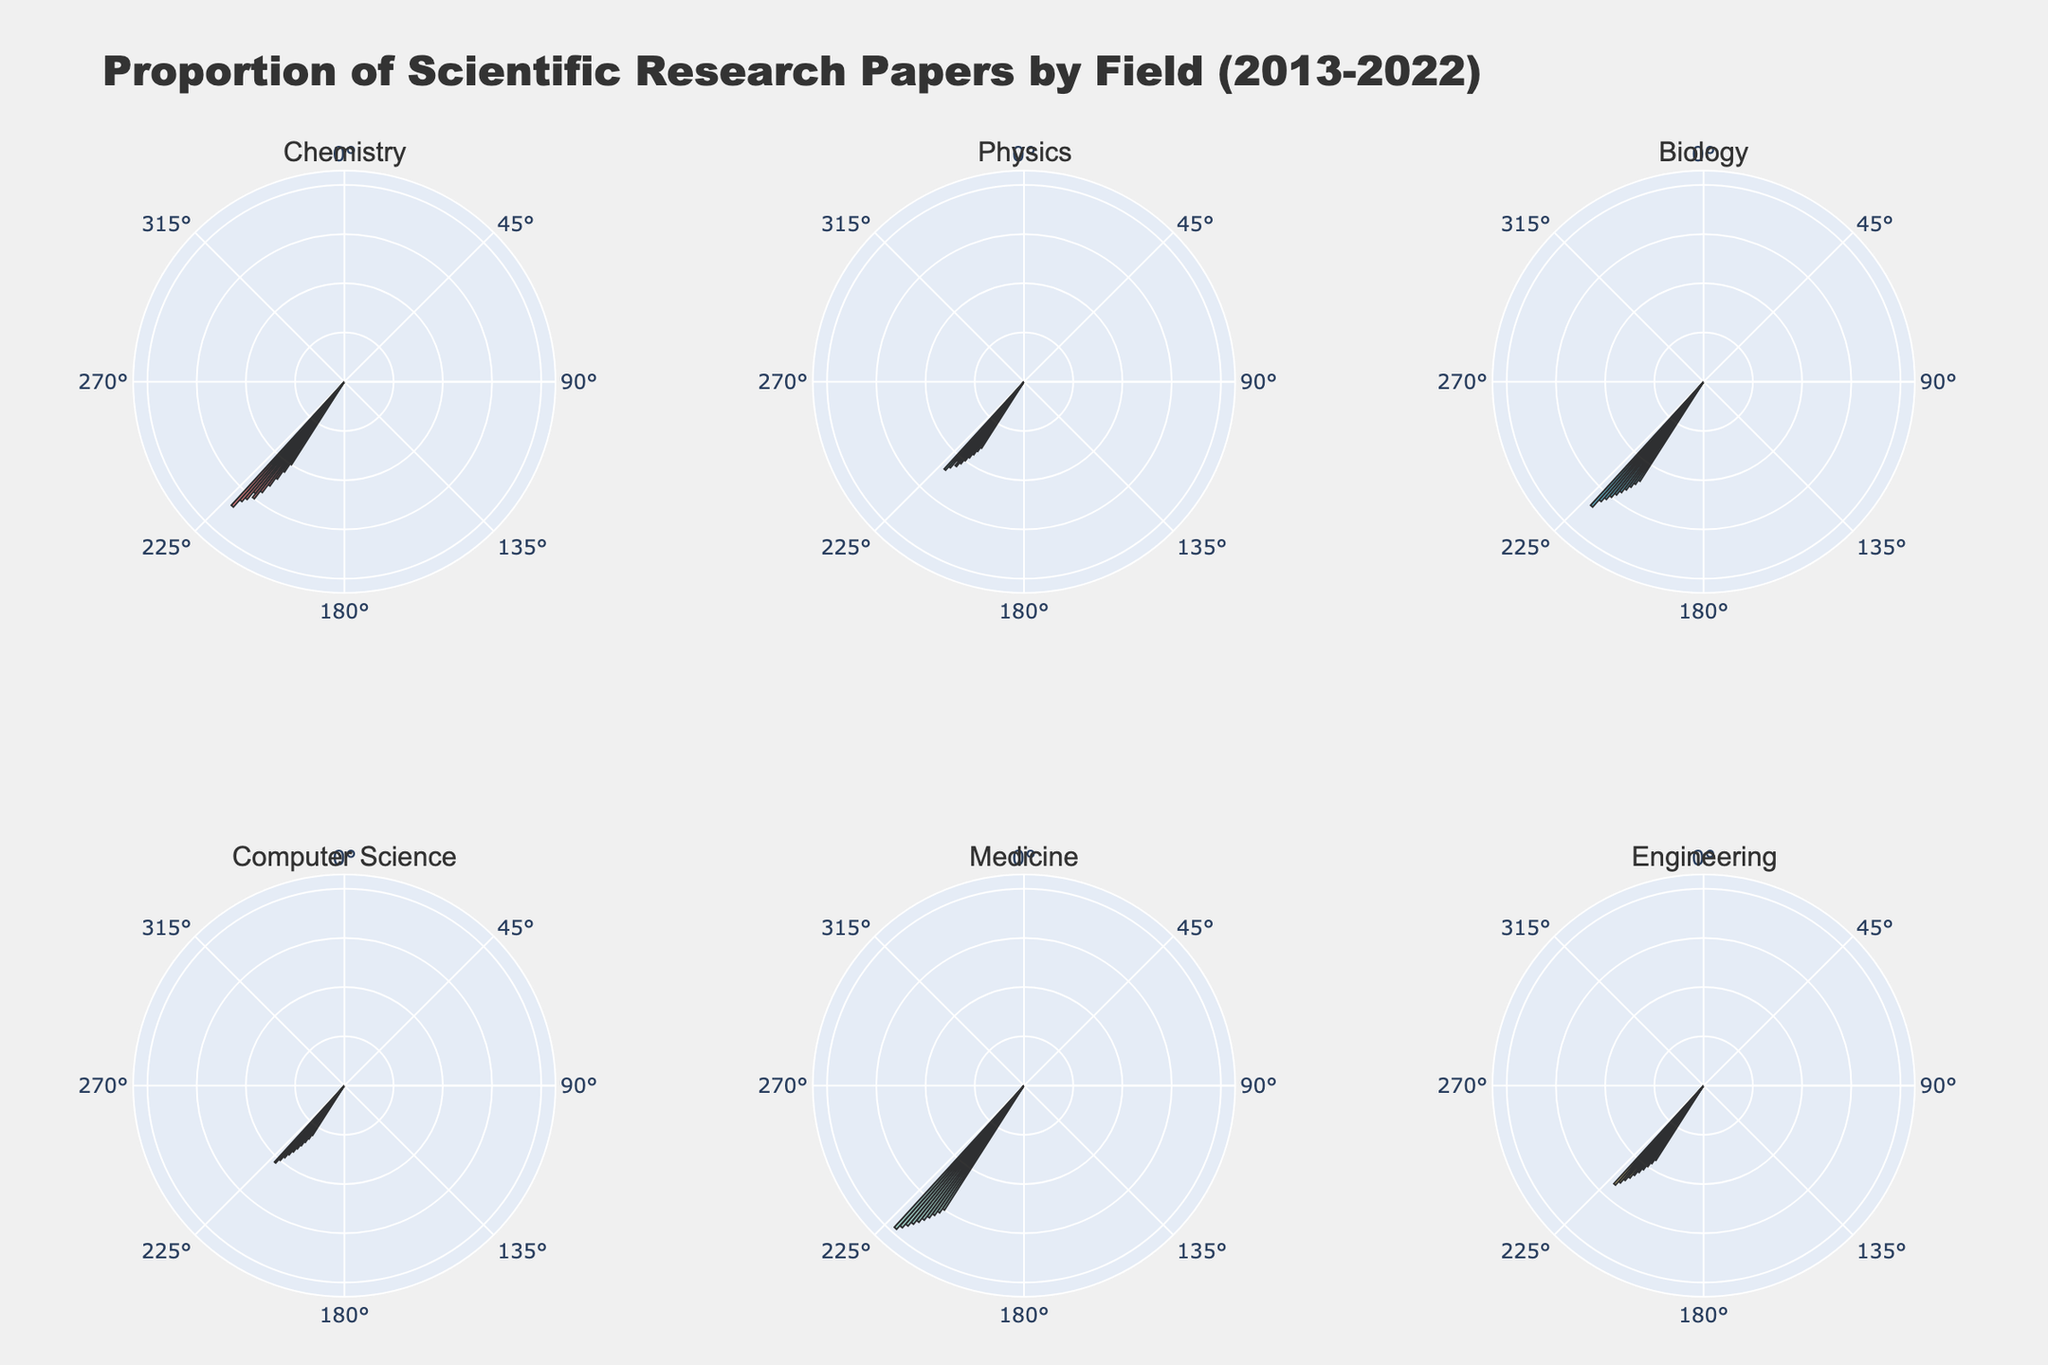How many fields are represented in the figure? The subplot titles indicate the number of fields in the figure; there are 6 subplot titles visible.
Answer: 6 Which field has the highest proportion of scientific research papers in the latest year (2022)? From the radial data in the subplots, the Medicine field shows the highest radial distance for 2022, indicating the highest proportion.
Answer: Medicine How did the proportion of scientific research papers in Chemistry change from 2013 to 2022? In the subplot for Chemistry, the radial distance starts at 10 in 2013 and increases to 17 in 2022, showing an increase of 7.
Answer: Increased by 7 Which two fields show the closest proportion of scientific research papers in 2020? By comparing radial distances for 2020 in each subplot, Chemistry and Biology both have proportions of 15.5, showing a close match.
Answer: Chemistry and Biology What is the overall trend observed for the proportion of research papers in Engineering from 2013 to 2022? The radial distance in the Engineering subplot shows a continuous upward trend from 9 in 2013 to 13.5 in 2022.
Answer: Increasing trend In which year did Physics see a unique drop in the proportion of scientific research papers? The subplot for Physics shows a drop in radial distance in 2020 compared to 2019, from 11 to 10.5.
Answer: 2020 Which field had the smallest proportion of research papers in 2013? The radial distance for Computer Science in 2013 is the smallest compared to the other fields, indicating the lowest proportion of 6.
Answer: Computer Science How does the average proportion of research papers in Medicine compare to that in Computer Science over the years 2013 to 2022? For Medicine, the average is (15+15.5+16+16.5+17+17.5+18+18.5+19+19.5)/10 = 16.7; for Computer Science, it is (6+6.5+7+7.5+8+8.5+9+9.5+10+10.5)/10 = 8.5. Thus, the average proportion in Medicine is much higher.
Answer: Medicine has a higher average proportion (16.7 vs. 8.5) Between Biology and Engineering, which field has a greater increase in the proportion of research papers from 2013 to 2022? In Biology, the increase is from 12 to 17 (an increase of 5), while in Engineering, it is from 9 to 13.5 (an increase of 4.5).
Answer: Biology (increase of 5) If you combine the proportion of research papers in Chemistry and Physics in 2015, what is the total proportion? In 2015, Chemistry has a proportion of 12 and Physics has 9. Summing them gives 12 + 9 = 21.
Answer: 21 